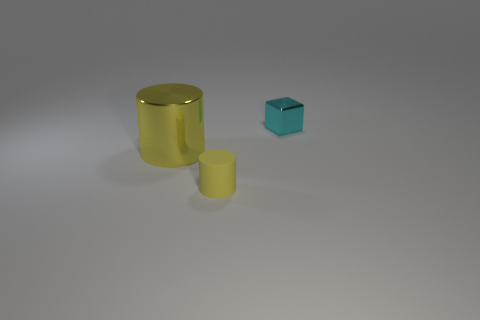Is the size of the thing behind the large shiny cylinder the same as the yellow cylinder in front of the large metal thing?
Keep it short and to the point. Yes. There is a metallic thing on the left side of the small thing that is in front of the shiny thing in front of the small cyan shiny object; what color is it?
Make the answer very short. Yellow. Are there any yellow matte things that have the same shape as the big metal thing?
Your response must be concise. Yes. Are there more yellow cylinders that are in front of the small cylinder than large gray spheres?
Give a very brief answer. No. How many matte objects are either small yellow things or yellow things?
Keep it short and to the point. 1. How big is the thing that is to the right of the large yellow metallic thing and left of the cyan metallic block?
Provide a short and direct response. Small. There is a small thing that is behind the tiny cylinder; are there any small blocks behind it?
Provide a short and direct response. No. There is a yellow metallic cylinder; how many yellow metal objects are left of it?
Keep it short and to the point. 0. What color is the other object that is the same shape as the large yellow metal thing?
Give a very brief answer. Yellow. Does the yellow cylinder right of the metal cylinder have the same material as the thing that is behind the yellow metallic cylinder?
Offer a terse response. No. 